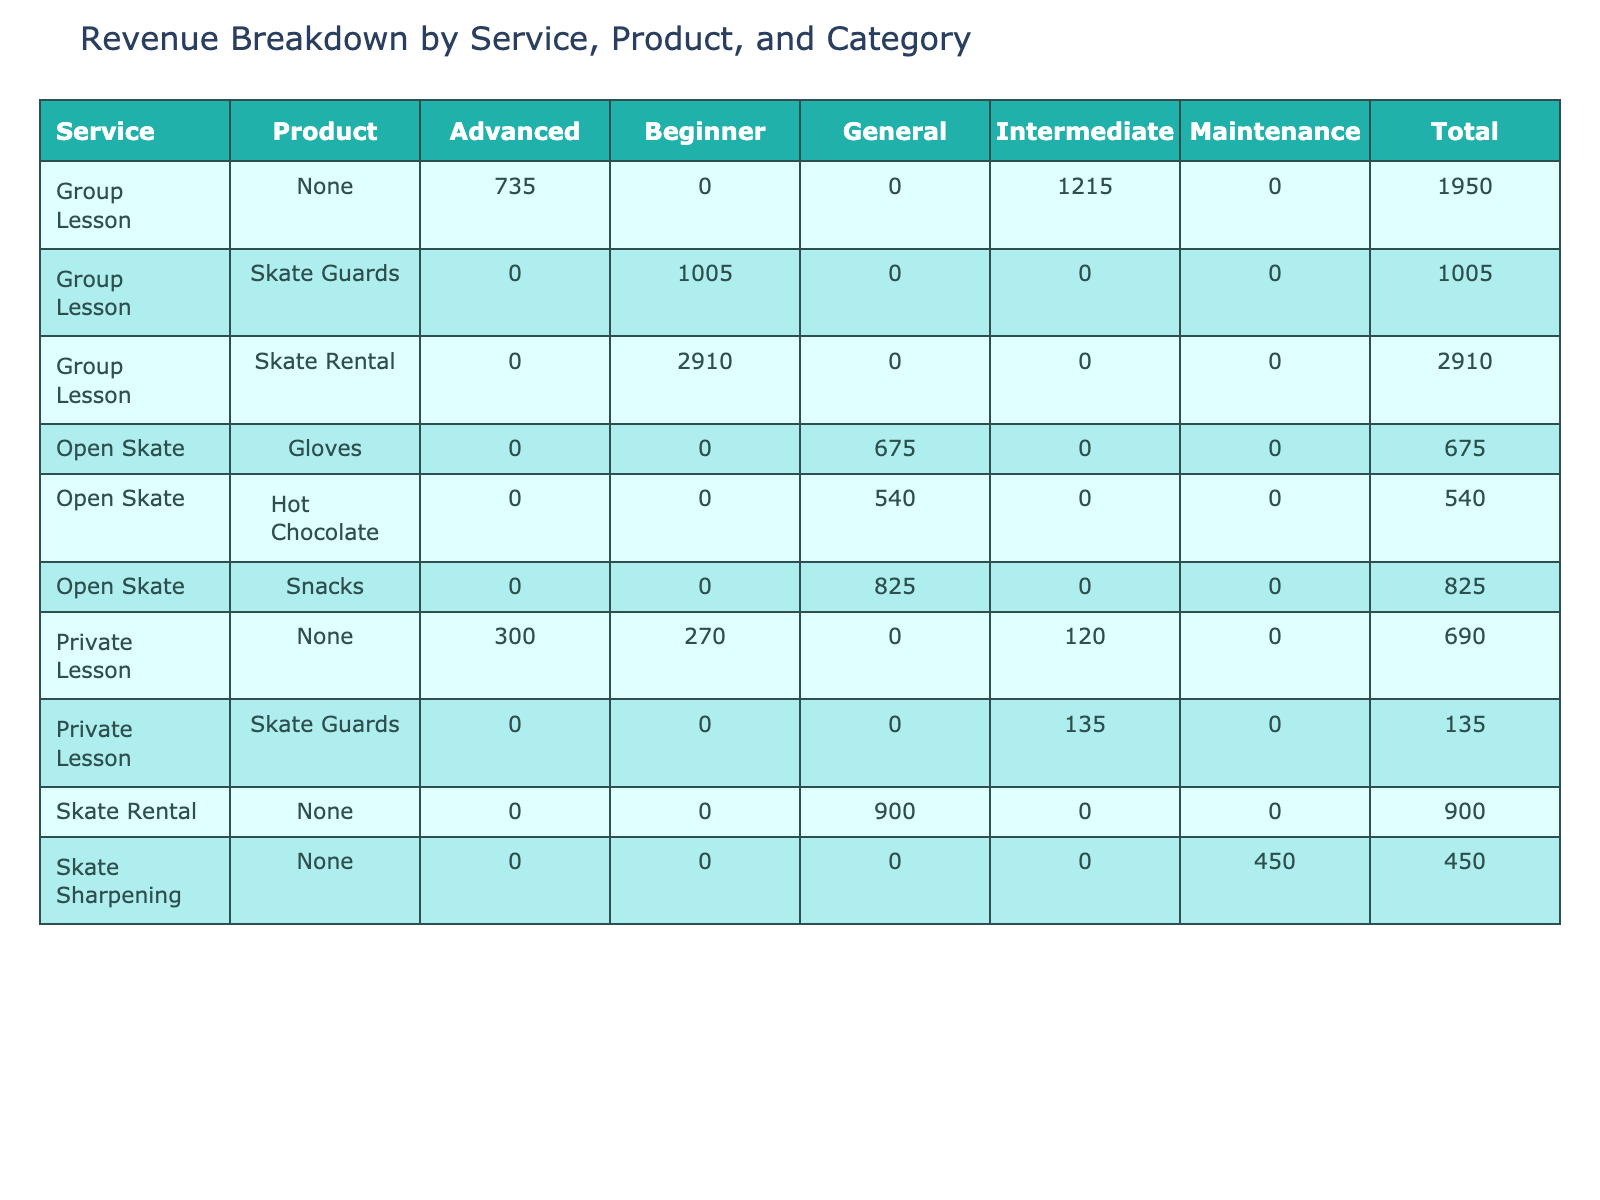What is the total revenue from skate rentals? In the pivot table, I can see all rows related to the "Skate Rental" product. The summed revenues for those entries are 450 + 480 + 300 + 450 + 510 + 480 + 315 + 540 = 2825.
Answer: 2825 How much revenue did the private lessons generate in total? The private lesson entries in the table show revenues of 120, 90, 150, and 135. Summing these values gives: 120 + 90 + 150 + 135 = 495.
Answer: 495 What was the most profitable service overall? By examining the total revenue column, I need to identify the service with the highest number. The revenues are: Group Lesson - 450 + 480 + 375 + 420 + 510 + 390 + 510 + 405 + 540 + 495 = 4565; Private Lesson - 495; Open Skate - 225 + 180 + 275 + 240 + 195 + 210 + 165 + 290 = 1690. The highest revenue is from Group Lesson at 4565.
Answer: Group Lesson Is there any revenue from skate sharpening services in the table? I can look for any entries that list "Skate Sharpening" in the service column. There are three entries with revenues 150, 135, and 165. Since there are revenues, the answer is yes.
Answer: Yes What is the average revenue generated from open skate sessions? First, I identify all the entries under "Open Skate" which are 225, 180, 275, 240, 195, 210, 165, 290. The total revenue from these sessions is 1690. There are 8 entries, so average revenue is 1690 divided by 8, resulting in 211.25.
Answer: 211.25 How many participants attended group lessons total? To find the total participants in group lessons, I need to sum the participant counts from the rows that specify "Group Lesson." Adding these values (15 + 16 + 12 + 14 + 17 + 15 + 17 + 13 + 16 = 135).
Answer: 135 What is the revenue breakdown by category for skate rentals? Reviewing the table shows skate rentals generate revenue across differences categories. The revenues are: General - 300, Beginner 2825; thus the breakdown is Beginner 2825 and General 300.
Answer: Beginner 2825, General 300 Did the revenue from snacks surpass the revenue from hot chocolate? I sum the snack revenues: 275 + 260 + 290 = 825 and the hot chocolate revenues: 180 + 195 + 165 = 540. Since 825 is greater than 540, the answer is yes.
Answer: Yes What was the lowest revenue from any service? To determine this, I need to compare all revenue figures presented in the table. The lowest revenue comes from the private lesson session with no associated product (90).
Answer: 90 